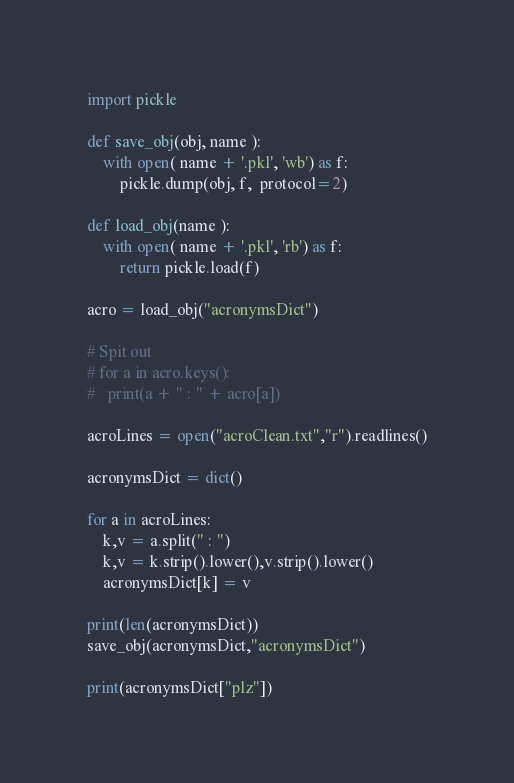<code> <loc_0><loc_0><loc_500><loc_500><_Python_>import pickle

def save_obj(obj, name ):
    with open( name + '.pkl', 'wb') as f:
        pickle.dump(obj, f,  protocol=2)

def load_obj(name ):
    with open( name + '.pkl', 'rb') as f:
        return pickle.load(f)

acro = load_obj("acronymsDict")

# Spit out
# for a in acro.keys():
# 	print(a + " : " + acro[a])

acroLines = open("acroClean.txt","r").readlines()

acronymsDict = dict()

for a in acroLines:
	k,v = a.split(" : ")
	k,v = k.strip().lower(),v.strip().lower()
	acronymsDict[k] = v

print(len(acronymsDict))
save_obj(acronymsDict,"acronymsDict")

print(acronymsDict["plz"])
</code> 